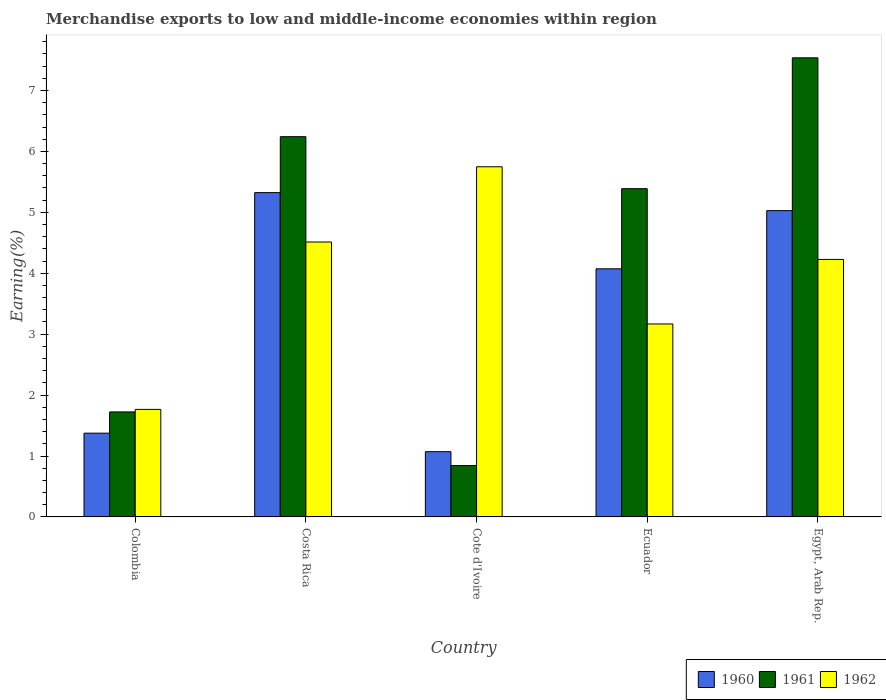How many groups of bars are there?
Your answer should be compact. 5. Are the number of bars on each tick of the X-axis equal?
Your answer should be compact. Yes. In how many cases, is the number of bars for a given country not equal to the number of legend labels?
Offer a very short reply. 0. What is the percentage of amount earned from merchandise exports in 1962 in Ecuador?
Offer a very short reply. 3.17. Across all countries, what is the maximum percentage of amount earned from merchandise exports in 1962?
Offer a very short reply. 5.75. Across all countries, what is the minimum percentage of amount earned from merchandise exports in 1960?
Your response must be concise. 1.07. In which country was the percentage of amount earned from merchandise exports in 1961 maximum?
Offer a terse response. Egypt, Arab Rep. In which country was the percentage of amount earned from merchandise exports in 1962 minimum?
Make the answer very short. Colombia. What is the total percentage of amount earned from merchandise exports in 1960 in the graph?
Keep it short and to the point. 16.87. What is the difference between the percentage of amount earned from merchandise exports in 1962 in Colombia and that in Ecuador?
Provide a succinct answer. -1.4. What is the difference between the percentage of amount earned from merchandise exports in 1960 in Colombia and the percentage of amount earned from merchandise exports in 1961 in Cote d'Ivoire?
Make the answer very short. 0.53. What is the average percentage of amount earned from merchandise exports in 1961 per country?
Offer a very short reply. 4.35. What is the difference between the percentage of amount earned from merchandise exports of/in 1962 and percentage of amount earned from merchandise exports of/in 1960 in Cote d'Ivoire?
Keep it short and to the point. 4.68. In how many countries, is the percentage of amount earned from merchandise exports in 1960 greater than 3 %?
Offer a terse response. 3. What is the ratio of the percentage of amount earned from merchandise exports in 1962 in Costa Rica to that in Ecuador?
Offer a terse response. 1.42. Is the percentage of amount earned from merchandise exports in 1962 in Cote d'Ivoire less than that in Egypt, Arab Rep.?
Make the answer very short. No. What is the difference between the highest and the second highest percentage of amount earned from merchandise exports in 1962?
Make the answer very short. -1.24. What is the difference between the highest and the lowest percentage of amount earned from merchandise exports in 1960?
Your answer should be compact. 4.25. Is the sum of the percentage of amount earned from merchandise exports in 1960 in Colombia and Cote d'Ivoire greater than the maximum percentage of amount earned from merchandise exports in 1962 across all countries?
Provide a short and direct response. No. What does the 1st bar from the left in Costa Rica represents?
Make the answer very short. 1960. How many bars are there?
Ensure brevity in your answer.  15. Are the values on the major ticks of Y-axis written in scientific E-notation?
Your answer should be very brief. No. Does the graph contain any zero values?
Provide a short and direct response. No. How many legend labels are there?
Your response must be concise. 3. What is the title of the graph?
Offer a terse response. Merchandise exports to low and middle-income economies within region. Does "2009" appear as one of the legend labels in the graph?
Keep it short and to the point. No. What is the label or title of the Y-axis?
Your answer should be compact. Earning(%). What is the Earning(%) of 1960 in Colombia?
Your answer should be compact. 1.38. What is the Earning(%) of 1961 in Colombia?
Your answer should be very brief. 1.72. What is the Earning(%) of 1962 in Colombia?
Make the answer very short. 1.77. What is the Earning(%) in 1960 in Costa Rica?
Your response must be concise. 5.32. What is the Earning(%) in 1961 in Costa Rica?
Ensure brevity in your answer.  6.24. What is the Earning(%) in 1962 in Costa Rica?
Provide a succinct answer. 4.51. What is the Earning(%) in 1960 in Cote d'Ivoire?
Keep it short and to the point. 1.07. What is the Earning(%) of 1961 in Cote d'Ivoire?
Ensure brevity in your answer.  0.84. What is the Earning(%) in 1962 in Cote d'Ivoire?
Offer a very short reply. 5.75. What is the Earning(%) of 1960 in Ecuador?
Provide a succinct answer. 4.07. What is the Earning(%) in 1961 in Ecuador?
Your answer should be very brief. 5.39. What is the Earning(%) in 1962 in Ecuador?
Your response must be concise. 3.17. What is the Earning(%) of 1960 in Egypt, Arab Rep.?
Your answer should be compact. 5.03. What is the Earning(%) of 1961 in Egypt, Arab Rep.?
Make the answer very short. 7.54. What is the Earning(%) of 1962 in Egypt, Arab Rep.?
Your answer should be very brief. 4.23. Across all countries, what is the maximum Earning(%) in 1960?
Offer a very short reply. 5.32. Across all countries, what is the maximum Earning(%) of 1961?
Provide a short and direct response. 7.54. Across all countries, what is the maximum Earning(%) of 1962?
Make the answer very short. 5.75. Across all countries, what is the minimum Earning(%) of 1960?
Give a very brief answer. 1.07. Across all countries, what is the minimum Earning(%) of 1961?
Ensure brevity in your answer.  0.84. Across all countries, what is the minimum Earning(%) of 1962?
Your answer should be compact. 1.77. What is the total Earning(%) of 1960 in the graph?
Ensure brevity in your answer.  16.87. What is the total Earning(%) in 1961 in the graph?
Your response must be concise. 21.73. What is the total Earning(%) of 1962 in the graph?
Provide a short and direct response. 19.42. What is the difference between the Earning(%) of 1960 in Colombia and that in Costa Rica?
Your response must be concise. -3.95. What is the difference between the Earning(%) of 1961 in Colombia and that in Costa Rica?
Keep it short and to the point. -4.52. What is the difference between the Earning(%) of 1962 in Colombia and that in Costa Rica?
Give a very brief answer. -2.75. What is the difference between the Earning(%) of 1960 in Colombia and that in Cote d'Ivoire?
Keep it short and to the point. 0.3. What is the difference between the Earning(%) of 1961 in Colombia and that in Cote d'Ivoire?
Give a very brief answer. 0.88. What is the difference between the Earning(%) in 1962 in Colombia and that in Cote d'Ivoire?
Your answer should be compact. -3.98. What is the difference between the Earning(%) of 1960 in Colombia and that in Ecuador?
Offer a terse response. -2.7. What is the difference between the Earning(%) in 1961 in Colombia and that in Ecuador?
Provide a succinct answer. -3.66. What is the difference between the Earning(%) of 1962 in Colombia and that in Ecuador?
Provide a short and direct response. -1.4. What is the difference between the Earning(%) in 1960 in Colombia and that in Egypt, Arab Rep.?
Your response must be concise. -3.65. What is the difference between the Earning(%) of 1961 in Colombia and that in Egypt, Arab Rep.?
Your answer should be compact. -5.81. What is the difference between the Earning(%) of 1962 in Colombia and that in Egypt, Arab Rep.?
Your answer should be very brief. -2.46. What is the difference between the Earning(%) in 1960 in Costa Rica and that in Cote d'Ivoire?
Keep it short and to the point. 4.25. What is the difference between the Earning(%) in 1961 in Costa Rica and that in Cote d'Ivoire?
Your answer should be compact. 5.4. What is the difference between the Earning(%) in 1962 in Costa Rica and that in Cote d'Ivoire?
Your answer should be compact. -1.24. What is the difference between the Earning(%) of 1960 in Costa Rica and that in Ecuador?
Provide a succinct answer. 1.25. What is the difference between the Earning(%) of 1961 in Costa Rica and that in Ecuador?
Provide a succinct answer. 0.85. What is the difference between the Earning(%) of 1962 in Costa Rica and that in Ecuador?
Keep it short and to the point. 1.35. What is the difference between the Earning(%) of 1960 in Costa Rica and that in Egypt, Arab Rep.?
Offer a very short reply. 0.3. What is the difference between the Earning(%) of 1961 in Costa Rica and that in Egypt, Arab Rep.?
Keep it short and to the point. -1.29. What is the difference between the Earning(%) in 1962 in Costa Rica and that in Egypt, Arab Rep.?
Provide a succinct answer. 0.29. What is the difference between the Earning(%) in 1960 in Cote d'Ivoire and that in Ecuador?
Offer a very short reply. -3. What is the difference between the Earning(%) of 1961 in Cote d'Ivoire and that in Ecuador?
Your response must be concise. -4.55. What is the difference between the Earning(%) in 1962 in Cote d'Ivoire and that in Ecuador?
Provide a short and direct response. 2.58. What is the difference between the Earning(%) in 1960 in Cote d'Ivoire and that in Egypt, Arab Rep.?
Your answer should be very brief. -3.96. What is the difference between the Earning(%) in 1961 in Cote d'Ivoire and that in Egypt, Arab Rep.?
Keep it short and to the point. -6.69. What is the difference between the Earning(%) of 1962 in Cote d'Ivoire and that in Egypt, Arab Rep.?
Offer a terse response. 1.52. What is the difference between the Earning(%) of 1960 in Ecuador and that in Egypt, Arab Rep.?
Your answer should be very brief. -0.96. What is the difference between the Earning(%) of 1961 in Ecuador and that in Egypt, Arab Rep.?
Provide a succinct answer. -2.15. What is the difference between the Earning(%) of 1962 in Ecuador and that in Egypt, Arab Rep.?
Make the answer very short. -1.06. What is the difference between the Earning(%) of 1960 in Colombia and the Earning(%) of 1961 in Costa Rica?
Your answer should be very brief. -4.87. What is the difference between the Earning(%) of 1960 in Colombia and the Earning(%) of 1962 in Costa Rica?
Provide a short and direct response. -3.14. What is the difference between the Earning(%) of 1961 in Colombia and the Earning(%) of 1962 in Costa Rica?
Provide a succinct answer. -2.79. What is the difference between the Earning(%) of 1960 in Colombia and the Earning(%) of 1961 in Cote d'Ivoire?
Your answer should be very brief. 0.53. What is the difference between the Earning(%) in 1960 in Colombia and the Earning(%) in 1962 in Cote d'Ivoire?
Offer a very short reply. -4.37. What is the difference between the Earning(%) of 1961 in Colombia and the Earning(%) of 1962 in Cote d'Ivoire?
Provide a succinct answer. -4.02. What is the difference between the Earning(%) of 1960 in Colombia and the Earning(%) of 1961 in Ecuador?
Offer a terse response. -4.01. What is the difference between the Earning(%) of 1960 in Colombia and the Earning(%) of 1962 in Ecuador?
Offer a terse response. -1.79. What is the difference between the Earning(%) in 1961 in Colombia and the Earning(%) in 1962 in Ecuador?
Provide a short and direct response. -1.44. What is the difference between the Earning(%) of 1960 in Colombia and the Earning(%) of 1961 in Egypt, Arab Rep.?
Make the answer very short. -6.16. What is the difference between the Earning(%) of 1960 in Colombia and the Earning(%) of 1962 in Egypt, Arab Rep.?
Offer a very short reply. -2.85. What is the difference between the Earning(%) of 1961 in Colombia and the Earning(%) of 1962 in Egypt, Arab Rep.?
Make the answer very short. -2.5. What is the difference between the Earning(%) of 1960 in Costa Rica and the Earning(%) of 1961 in Cote d'Ivoire?
Give a very brief answer. 4.48. What is the difference between the Earning(%) in 1960 in Costa Rica and the Earning(%) in 1962 in Cote d'Ivoire?
Your answer should be compact. -0.42. What is the difference between the Earning(%) in 1961 in Costa Rica and the Earning(%) in 1962 in Cote d'Ivoire?
Ensure brevity in your answer.  0.49. What is the difference between the Earning(%) in 1960 in Costa Rica and the Earning(%) in 1961 in Ecuador?
Provide a succinct answer. -0.06. What is the difference between the Earning(%) of 1960 in Costa Rica and the Earning(%) of 1962 in Ecuador?
Offer a very short reply. 2.16. What is the difference between the Earning(%) in 1961 in Costa Rica and the Earning(%) in 1962 in Ecuador?
Provide a succinct answer. 3.07. What is the difference between the Earning(%) of 1960 in Costa Rica and the Earning(%) of 1961 in Egypt, Arab Rep.?
Your response must be concise. -2.21. What is the difference between the Earning(%) of 1960 in Costa Rica and the Earning(%) of 1962 in Egypt, Arab Rep.?
Offer a very short reply. 1.1. What is the difference between the Earning(%) in 1961 in Costa Rica and the Earning(%) in 1962 in Egypt, Arab Rep.?
Ensure brevity in your answer.  2.02. What is the difference between the Earning(%) of 1960 in Cote d'Ivoire and the Earning(%) of 1961 in Ecuador?
Provide a short and direct response. -4.32. What is the difference between the Earning(%) in 1960 in Cote d'Ivoire and the Earning(%) in 1962 in Ecuador?
Offer a terse response. -2.1. What is the difference between the Earning(%) of 1961 in Cote d'Ivoire and the Earning(%) of 1962 in Ecuador?
Your answer should be very brief. -2.32. What is the difference between the Earning(%) in 1960 in Cote d'Ivoire and the Earning(%) in 1961 in Egypt, Arab Rep.?
Offer a very short reply. -6.47. What is the difference between the Earning(%) of 1960 in Cote d'Ivoire and the Earning(%) of 1962 in Egypt, Arab Rep.?
Offer a very short reply. -3.16. What is the difference between the Earning(%) in 1961 in Cote d'Ivoire and the Earning(%) in 1962 in Egypt, Arab Rep.?
Your answer should be very brief. -3.38. What is the difference between the Earning(%) in 1960 in Ecuador and the Earning(%) in 1961 in Egypt, Arab Rep.?
Provide a succinct answer. -3.46. What is the difference between the Earning(%) of 1960 in Ecuador and the Earning(%) of 1962 in Egypt, Arab Rep.?
Your answer should be very brief. -0.15. What is the difference between the Earning(%) in 1961 in Ecuador and the Earning(%) in 1962 in Egypt, Arab Rep.?
Offer a very short reply. 1.16. What is the average Earning(%) in 1960 per country?
Provide a short and direct response. 3.37. What is the average Earning(%) in 1961 per country?
Offer a terse response. 4.35. What is the average Earning(%) in 1962 per country?
Offer a terse response. 3.88. What is the difference between the Earning(%) of 1960 and Earning(%) of 1961 in Colombia?
Provide a succinct answer. -0.35. What is the difference between the Earning(%) of 1960 and Earning(%) of 1962 in Colombia?
Offer a very short reply. -0.39. What is the difference between the Earning(%) in 1961 and Earning(%) in 1962 in Colombia?
Your response must be concise. -0.04. What is the difference between the Earning(%) of 1960 and Earning(%) of 1961 in Costa Rica?
Your answer should be very brief. -0.92. What is the difference between the Earning(%) in 1960 and Earning(%) in 1962 in Costa Rica?
Your response must be concise. 0.81. What is the difference between the Earning(%) in 1961 and Earning(%) in 1962 in Costa Rica?
Provide a short and direct response. 1.73. What is the difference between the Earning(%) of 1960 and Earning(%) of 1961 in Cote d'Ivoire?
Your answer should be very brief. 0.23. What is the difference between the Earning(%) of 1960 and Earning(%) of 1962 in Cote d'Ivoire?
Provide a succinct answer. -4.68. What is the difference between the Earning(%) of 1961 and Earning(%) of 1962 in Cote d'Ivoire?
Offer a terse response. -4.91. What is the difference between the Earning(%) in 1960 and Earning(%) in 1961 in Ecuador?
Your answer should be compact. -1.32. What is the difference between the Earning(%) in 1960 and Earning(%) in 1962 in Ecuador?
Provide a succinct answer. 0.91. What is the difference between the Earning(%) in 1961 and Earning(%) in 1962 in Ecuador?
Make the answer very short. 2.22. What is the difference between the Earning(%) in 1960 and Earning(%) in 1961 in Egypt, Arab Rep.?
Provide a short and direct response. -2.51. What is the difference between the Earning(%) in 1960 and Earning(%) in 1962 in Egypt, Arab Rep.?
Offer a terse response. 0.8. What is the difference between the Earning(%) in 1961 and Earning(%) in 1962 in Egypt, Arab Rep.?
Offer a terse response. 3.31. What is the ratio of the Earning(%) of 1960 in Colombia to that in Costa Rica?
Provide a short and direct response. 0.26. What is the ratio of the Earning(%) of 1961 in Colombia to that in Costa Rica?
Give a very brief answer. 0.28. What is the ratio of the Earning(%) of 1962 in Colombia to that in Costa Rica?
Your response must be concise. 0.39. What is the ratio of the Earning(%) in 1960 in Colombia to that in Cote d'Ivoire?
Offer a terse response. 1.28. What is the ratio of the Earning(%) in 1961 in Colombia to that in Cote d'Ivoire?
Your response must be concise. 2.04. What is the ratio of the Earning(%) in 1962 in Colombia to that in Cote d'Ivoire?
Your answer should be compact. 0.31. What is the ratio of the Earning(%) in 1960 in Colombia to that in Ecuador?
Offer a very short reply. 0.34. What is the ratio of the Earning(%) of 1961 in Colombia to that in Ecuador?
Provide a short and direct response. 0.32. What is the ratio of the Earning(%) in 1962 in Colombia to that in Ecuador?
Make the answer very short. 0.56. What is the ratio of the Earning(%) in 1960 in Colombia to that in Egypt, Arab Rep.?
Provide a short and direct response. 0.27. What is the ratio of the Earning(%) of 1961 in Colombia to that in Egypt, Arab Rep.?
Ensure brevity in your answer.  0.23. What is the ratio of the Earning(%) of 1962 in Colombia to that in Egypt, Arab Rep.?
Your response must be concise. 0.42. What is the ratio of the Earning(%) in 1960 in Costa Rica to that in Cote d'Ivoire?
Ensure brevity in your answer.  4.97. What is the ratio of the Earning(%) of 1961 in Costa Rica to that in Cote d'Ivoire?
Make the answer very short. 7.4. What is the ratio of the Earning(%) of 1962 in Costa Rica to that in Cote d'Ivoire?
Give a very brief answer. 0.79. What is the ratio of the Earning(%) in 1960 in Costa Rica to that in Ecuador?
Offer a terse response. 1.31. What is the ratio of the Earning(%) in 1961 in Costa Rica to that in Ecuador?
Offer a terse response. 1.16. What is the ratio of the Earning(%) of 1962 in Costa Rica to that in Ecuador?
Offer a very short reply. 1.42. What is the ratio of the Earning(%) in 1960 in Costa Rica to that in Egypt, Arab Rep.?
Provide a succinct answer. 1.06. What is the ratio of the Earning(%) in 1961 in Costa Rica to that in Egypt, Arab Rep.?
Offer a terse response. 0.83. What is the ratio of the Earning(%) of 1962 in Costa Rica to that in Egypt, Arab Rep.?
Keep it short and to the point. 1.07. What is the ratio of the Earning(%) in 1960 in Cote d'Ivoire to that in Ecuador?
Your response must be concise. 0.26. What is the ratio of the Earning(%) in 1961 in Cote d'Ivoire to that in Ecuador?
Provide a succinct answer. 0.16. What is the ratio of the Earning(%) in 1962 in Cote d'Ivoire to that in Ecuador?
Offer a terse response. 1.81. What is the ratio of the Earning(%) of 1960 in Cote d'Ivoire to that in Egypt, Arab Rep.?
Provide a succinct answer. 0.21. What is the ratio of the Earning(%) in 1961 in Cote d'Ivoire to that in Egypt, Arab Rep.?
Your answer should be compact. 0.11. What is the ratio of the Earning(%) of 1962 in Cote d'Ivoire to that in Egypt, Arab Rep.?
Offer a terse response. 1.36. What is the ratio of the Earning(%) of 1960 in Ecuador to that in Egypt, Arab Rep.?
Give a very brief answer. 0.81. What is the ratio of the Earning(%) of 1961 in Ecuador to that in Egypt, Arab Rep.?
Make the answer very short. 0.71. What is the ratio of the Earning(%) of 1962 in Ecuador to that in Egypt, Arab Rep.?
Offer a terse response. 0.75. What is the difference between the highest and the second highest Earning(%) in 1960?
Give a very brief answer. 0.3. What is the difference between the highest and the second highest Earning(%) of 1961?
Make the answer very short. 1.29. What is the difference between the highest and the second highest Earning(%) of 1962?
Ensure brevity in your answer.  1.24. What is the difference between the highest and the lowest Earning(%) of 1960?
Offer a very short reply. 4.25. What is the difference between the highest and the lowest Earning(%) in 1961?
Keep it short and to the point. 6.69. What is the difference between the highest and the lowest Earning(%) in 1962?
Keep it short and to the point. 3.98. 